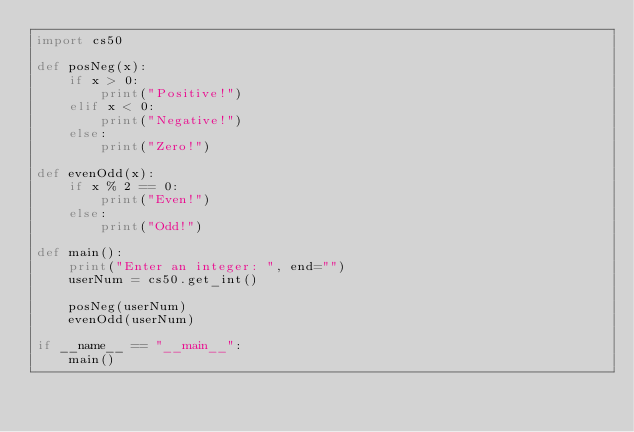Convert code to text. <code><loc_0><loc_0><loc_500><loc_500><_Python_>import cs50

def posNeg(x):
    if x > 0:
        print("Positive!")
    elif x < 0:
        print("Negative!")
    else:
        print("Zero!")
        
def evenOdd(x):
    if x % 2 == 0:
        print("Even!")
    else:
        print("Odd!")

def main():
    print("Enter an integer: ", end="")
    userNum = cs50.get_int()
    
    posNeg(userNum)
    evenOdd(userNum)

if __name__ == "__main__":
    main()</code> 